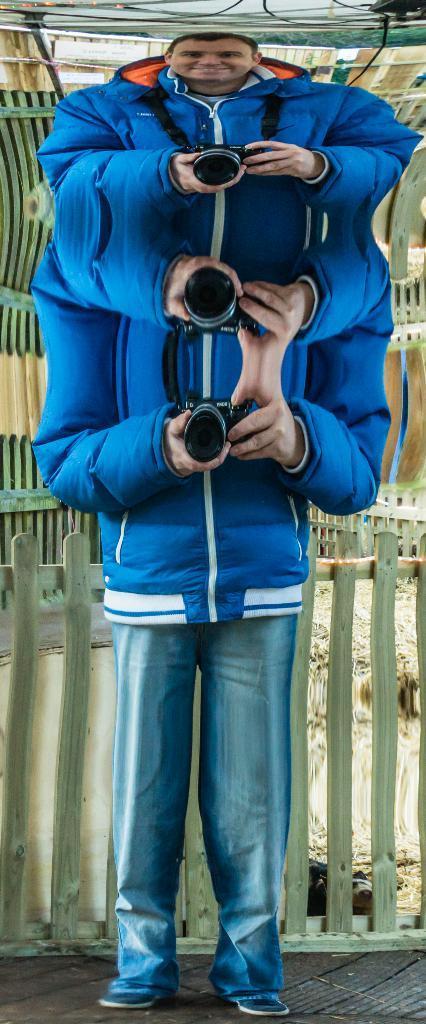Could you give a brief overview of what you see in this image? This is an edited image in this image in the center there is one person who is holding a camera, and in the background there is a fence. At the bottom there is a walkway. 